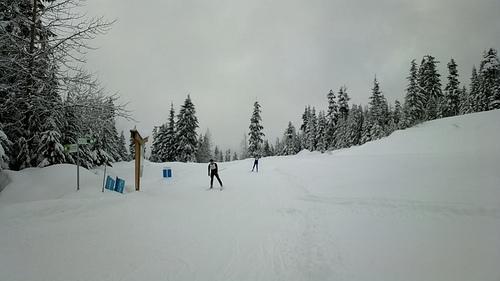Question: what is in the photo?
Choices:
A. Mountains.
B. Ocean.
C. Snow and trees.
D. Lion.
Answer with the letter. Answer: C 